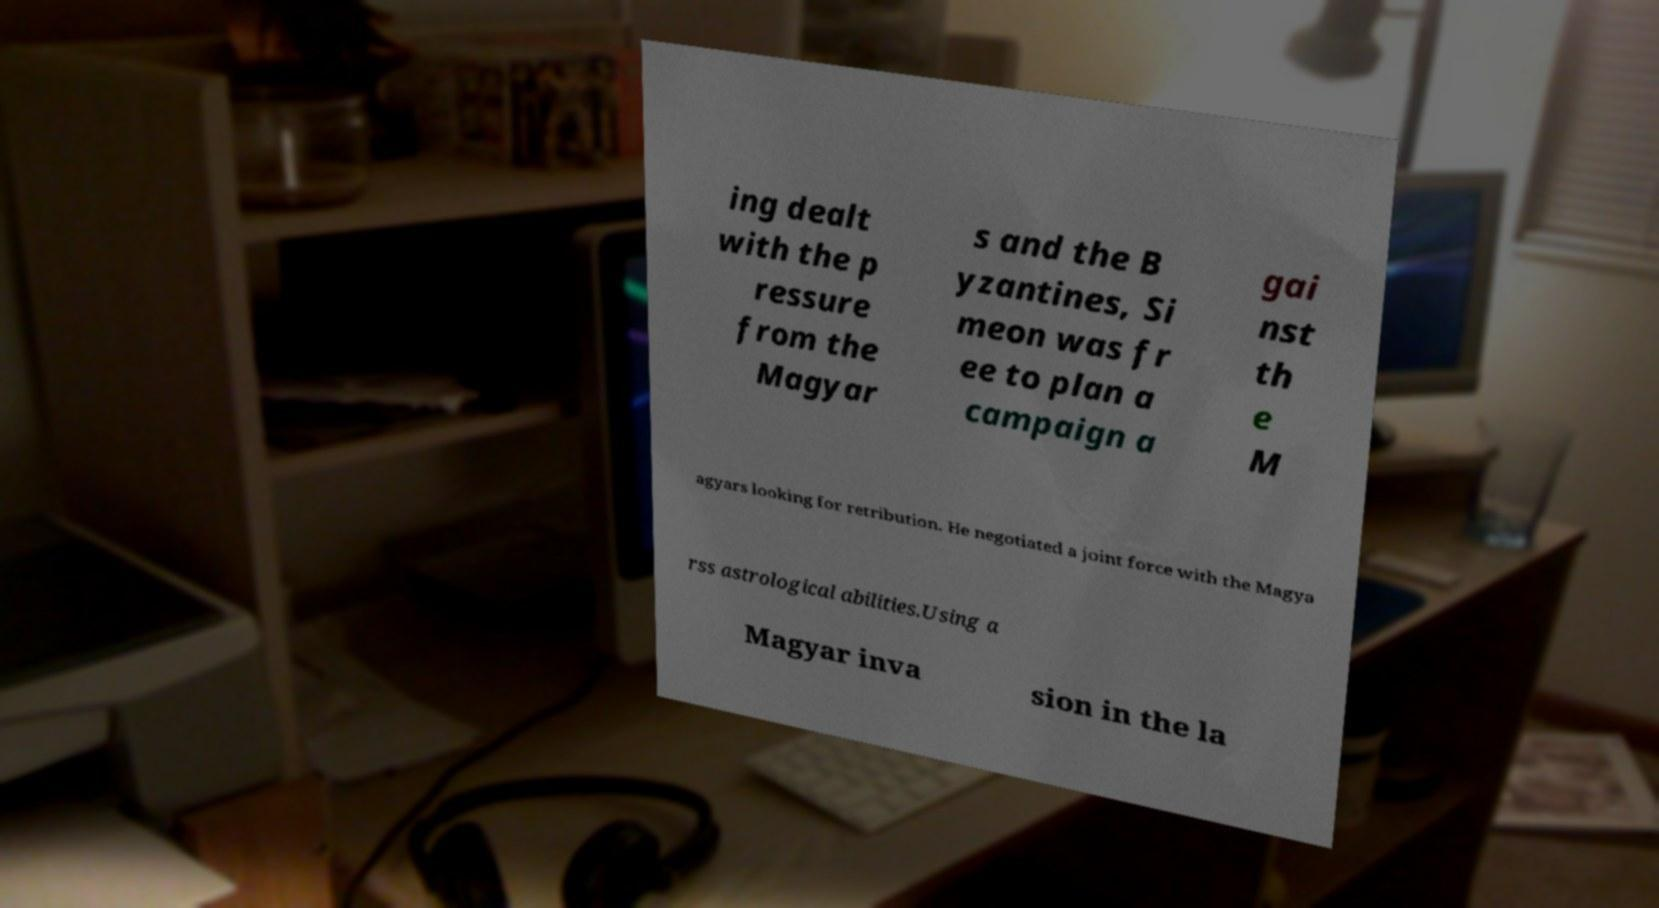For documentation purposes, I need the text within this image transcribed. Could you provide that? ing dealt with the p ressure from the Magyar s and the B yzantines, Si meon was fr ee to plan a campaign a gai nst th e M agyars looking for retribution. He negotiated a joint force with the Magya rss astrological abilities.Using a Magyar inva sion in the la 